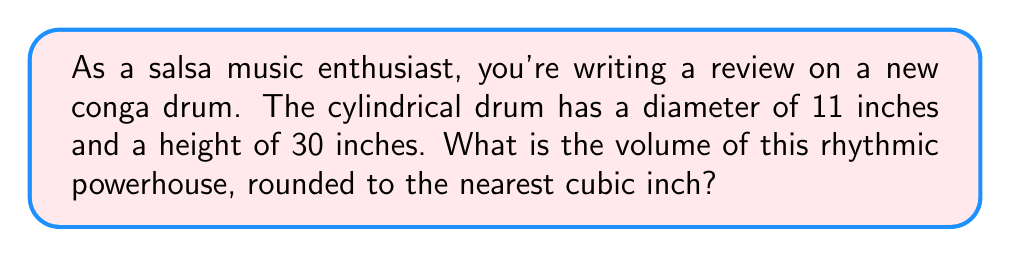Show me your answer to this math problem. Let's approach this step-by-step:

1) The formula for the volume of a cylinder is:
   $$V = \pi r^2 h$$
   where $r$ is the radius and $h$ is the height.

2) We're given the diameter (11 inches), so we need to find the radius:
   $$r = \frac{diameter}{2} = \frac{11}{2} = 5.5\text{ inches}$$

3) We're also given the height: $h = 30\text{ inches}$

4) Now, let's substitute these values into our formula:
   $$V = \pi (5.5\text{ in})^2 (30\text{ in})$$

5) Let's calculate:
   $$V = \pi (30.25\text{ sq in})(30\text{ in})$$
   $$V = 907.5\pi\text{ cubic inches}$$

6) Using 3.14159 as an approximation for $\pi$:
   $$V \approx 2850.71\text{ cubic inches}$$

7) Rounding to the nearest cubic inch:
   $$V \approx 2851\text{ cubic inches}$$

This impressive volume contributes to the deep, resonant tones that make the conga drum an essential part of any salsa ensemble.
Answer: 2851 cubic inches 